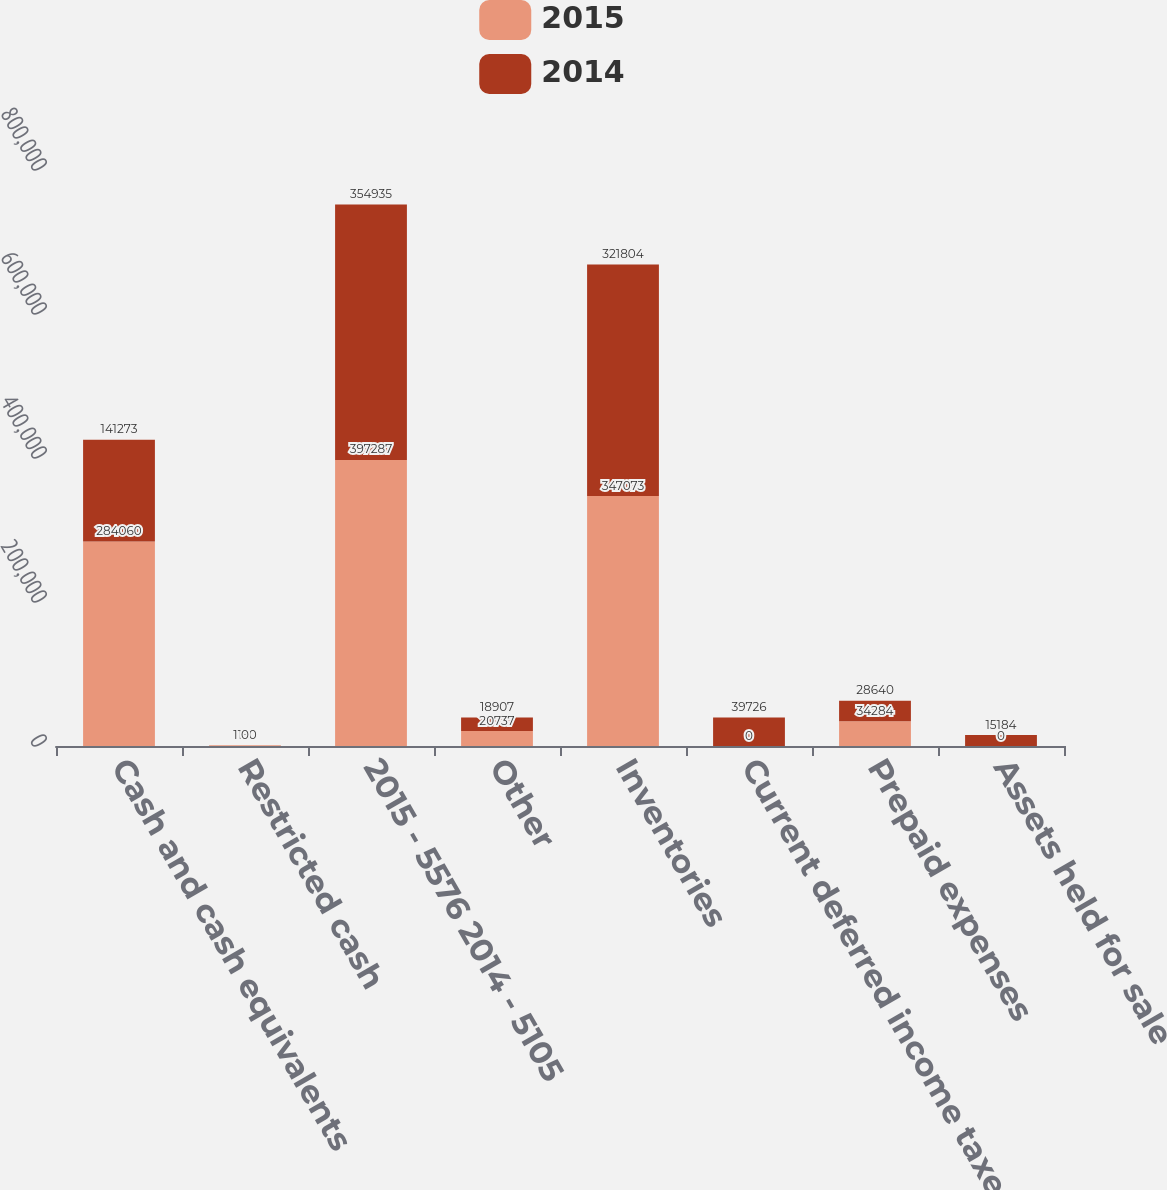Convert chart. <chart><loc_0><loc_0><loc_500><loc_500><stacked_bar_chart><ecel><fcel>Cash and cash equivalents<fcel>Restricted cash<fcel>2015 - 5576 2014 - 5105<fcel>Other<fcel>Inventories<fcel>Current deferred income taxes<fcel>Prepaid expenses<fcel>Assets held for sale<nl><fcel>2015<fcel>284060<fcel>1150<fcel>397287<fcel>20737<fcel>347073<fcel>0<fcel>34284<fcel>0<nl><fcel>2014<fcel>141273<fcel>0<fcel>354935<fcel>18907<fcel>321804<fcel>39726<fcel>28640<fcel>15184<nl></chart> 